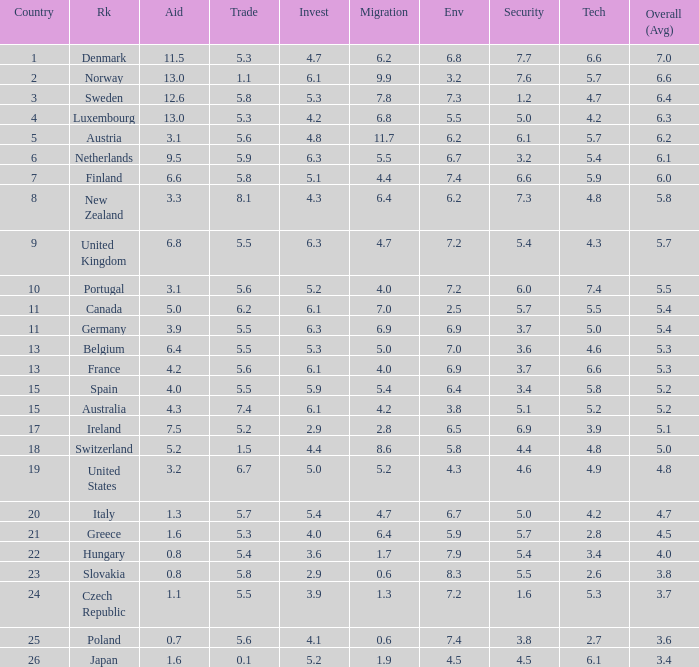How many times is denmark ranked in technology? 1.0. 